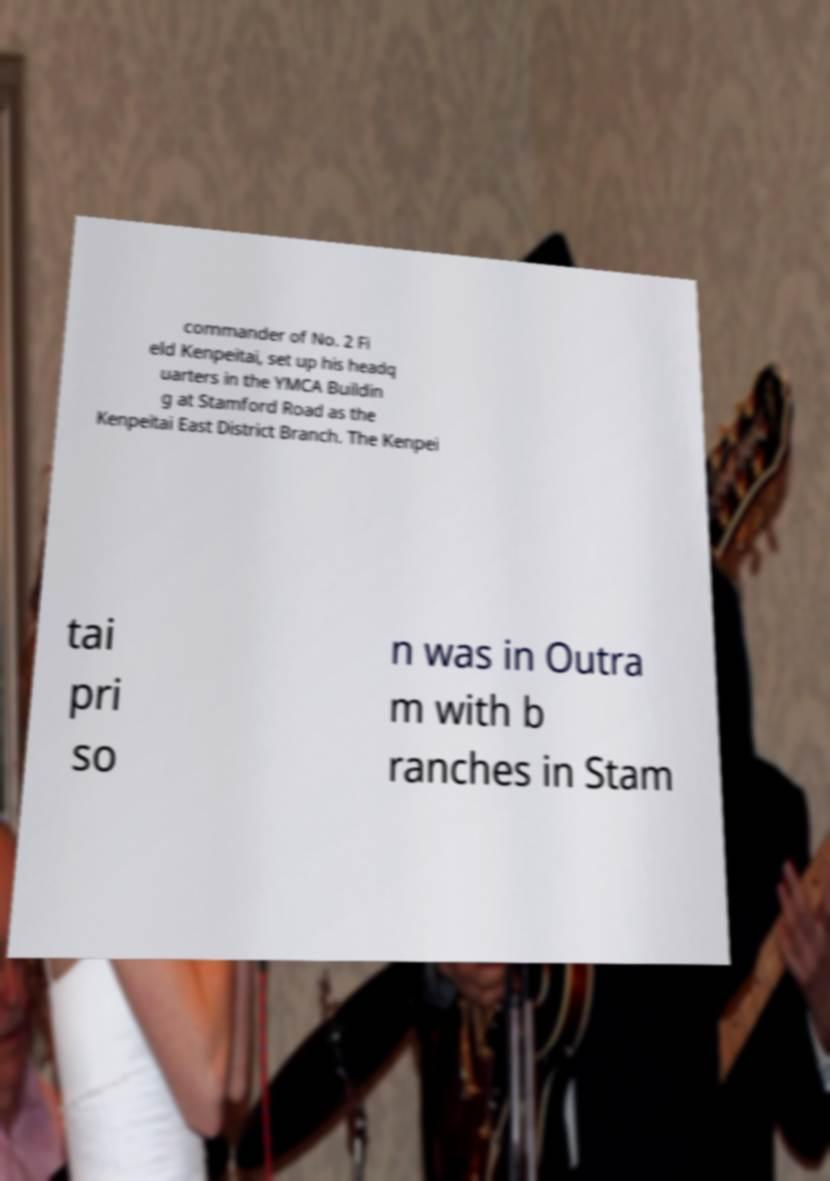Can you accurately transcribe the text from the provided image for me? commander of No. 2 Fi eld Kenpeitai, set up his headq uarters in the YMCA Buildin g at Stamford Road as the Kenpeitai East District Branch. The Kenpei tai pri so n was in Outra m with b ranches in Stam 